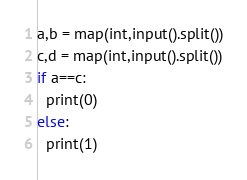<code> <loc_0><loc_0><loc_500><loc_500><_Python_>a,b = map(int,input().split())
c,d = map(int,input().split())
if a==c:
  print(0)
else:
  print(1)</code> 